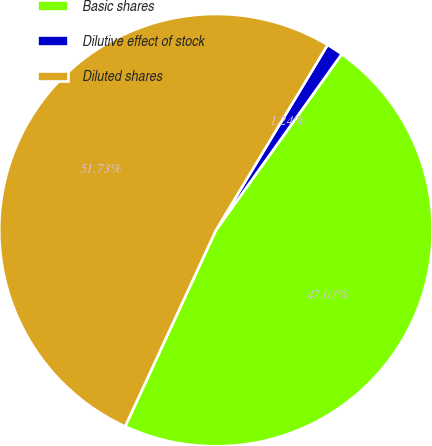Convert chart. <chart><loc_0><loc_0><loc_500><loc_500><pie_chart><fcel>Basic shares<fcel>Dilutive effect of stock<fcel>Diluted shares<nl><fcel>47.03%<fcel>1.24%<fcel>51.73%<nl></chart> 